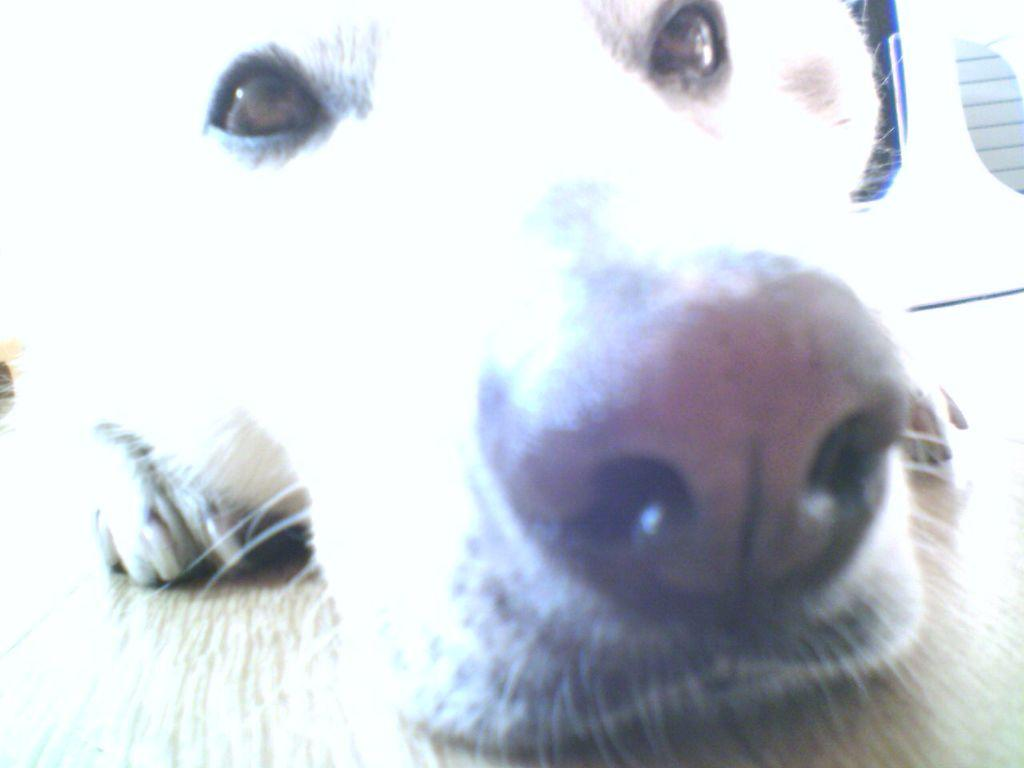What type of animal is present in the image? There is a dog in the image. What is the color of the dog? The dog is white in color. Where is the dog located in the image? The dog is on the floor. How many geese are present in the image? There are no geese present in the image; it features a white dog on the floor. Is there a cellar visible in the image? There is no cellar present in the image. What type of grain is being stored in the image? There is no grain present in the image. 